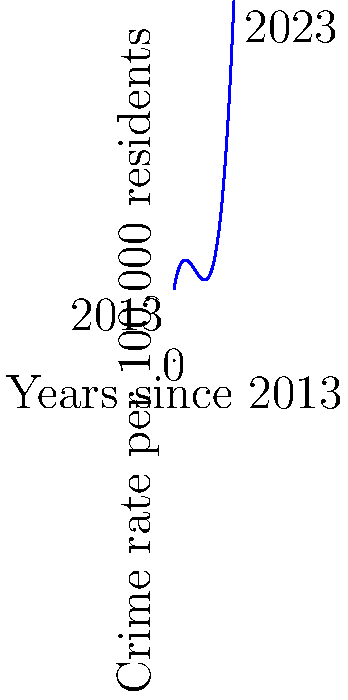As a conservative news reporter in Richmond, Virginia, you're analyzing the city's crime rate trends over the past decade. The polynomial function $f(x) = 0.2x^3 - 2.1x^2 + 5.8x + 12$ represents the crime rate per 100,000 residents, where $x$ is the number of years since 2013. Based on this function, what was the approximate year when Richmond experienced its lowest crime rate, and what policy implications might this have for the city? To find the year with the lowest crime rate, we need to determine the minimum point of the polynomial function. Here's how we can do this:

1) First, we need to find the derivative of the function:
   $f'(x) = 0.6x^2 - 4.2x + 5.8$

2) Set the derivative to zero to find critical points:
   $0.6x^2 - 4.2x + 5.8 = 0$

3) Solve this quadratic equation:
   $x = \frac{4.2 \pm \sqrt{4.2^2 - 4(0.6)(5.8)}}{2(0.6)}$
   $x \approx 3.5$ or $x \approx 3.5$

4) The critical point occurs at $x \approx 3.5$, which corresponds to mid-2016.

5) To confirm this is a minimum, we can check the second derivative:
   $f''(x) = 1.2x - 4.2$
   At $x = 3.5$, $f''(3.5) = 0.2 > 0$, confirming it's a minimum.

Therefore, the crime rate was lowest around mid-2016, about 3.5 years after 2013.

Policy implications:
1) Investigate what specific policies or initiatives were in place in 2016 that might have contributed to the lower crime rate.
2) Consider reintroducing or strengthening these policies.
3) Analyze factors that may have contributed to the subsequent increase in crime rates.
4) Develop targeted strategies to address the recent upward trend in crime rates.
Answer: Mid-2016; reassess and potentially reinstate effective 2016 policies 